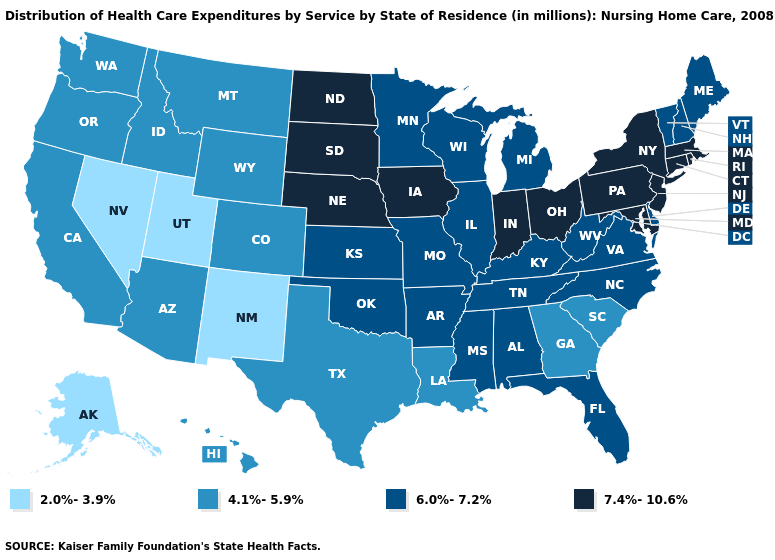Does Nevada have the highest value in the USA?
Be succinct. No. What is the value of Maryland?
Answer briefly. 7.4%-10.6%. Is the legend a continuous bar?
Answer briefly. No. Name the states that have a value in the range 2.0%-3.9%?
Concise answer only. Alaska, Nevada, New Mexico, Utah. Name the states that have a value in the range 4.1%-5.9%?
Quick response, please. Arizona, California, Colorado, Georgia, Hawaii, Idaho, Louisiana, Montana, Oregon, South Carolina, Texas, Washington, Wyoming. Does Alabama have the lowest value in the USA?
Give a very brief answer. No. What is the value of South Carolina?
Give a very brief answer. 4.1%-5.9%. Is the legend a continuous bar?
Be succinct. No. Does Maryland have the highest value in the South?
Quick response, please. Yes. Does the map have missing data?
Concise answer only. No. Does Texas have the lowest value in the USA?
Answer briefly. No. Does West Virginia have a lower value than Washington?
Short answer required. No. Does Alaska have the same value as Nevada?
Keep it brief. Yes. Name the states that have a value in the range 6.0%-7.2%?
Give a very brief answer. Alabama, Arkansas, Delaware, Florida, Illinois, Kansas, Kentucky, Maine, Michigan, Minnesota, Mississippi, Missouri, New Hampshire, North Carolina, Oklahoma, Tennessee, Vermont, Virginia, West Virginia, Wisconsin. What is the value of Iowa?
Write a very short answer. 7.4%-10.6%. 